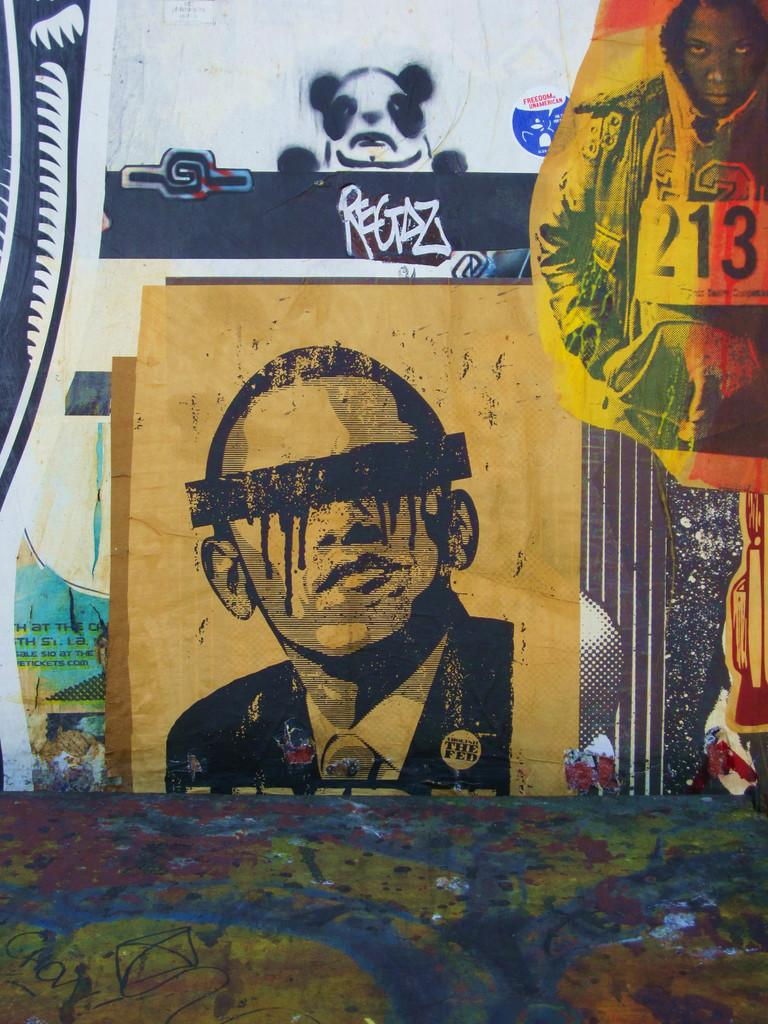Provide a one-sentence caption for the provided image. A collection of graffiti art includes a painting of Obama wearing an anti Fed button. 